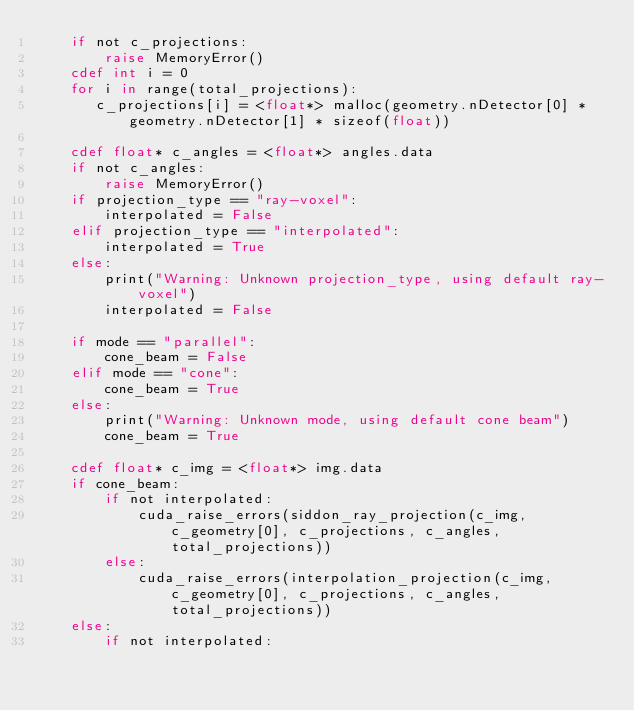<code> <loc_0><loc_0><loc_500><loc_500><_Cython_>    if not c_projections:
        raise MemoryError()
    cdef int i = 0
    for i in range(total_projections):
       c_projections[i] = <float*> malloc(geometry.nDetector[0] * geometry.nDetector[1] * sizeof(float))

    cdef float* c_angles = <float*> angles.data
    if not c_angles:
        raise MemoryError()
    if projection_type == "ray-voxel":
        interpolated = False
    elif projection_type == "interpolated":
        interpolated = True
    else:
        print("Warning: Unknown projection_type, using default ray-voxel")
        interpolated = False

    if mode == "parallel":
        cone_beam = False
    elif mode == "cone":
        cone_beam = True
    else:
        print("Warning: Unknown mode, using default cone beam")
        cone_beam = True

    cdef float* c_img = <float*> img.data
    if cone_beam:
        if not interpolated:
            cuda_raise_errors(siddon_ray_projection(c_img, c_geometry[0], c_projections, c_angles, total_projections))
        else:
            cuda_raise_errors(interpolation_projection(c_img, c_geometry[0], c_projections, c_angles, total_projections))
    else:
        if not interpolated:</code> 